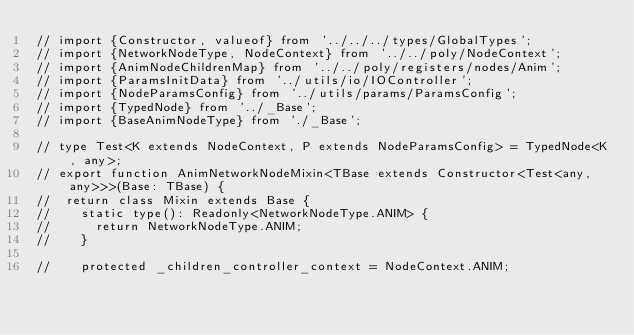<code> <loc_0><loc_0><loc_500><loc_500><_TypeScript_>// import {Constructor, valueof} from '../../../types/GlobalTypes';
// import {NetworkNodeType, NodeContext} from '../../poly/NodeContext';
// import {AnimNodeChildrenMap} from '../../poly/registers/nodes/Anim';
// import {ParamsInitData} from '../utils/io/IOController';
// import {NodeParamsConfig} from '../utils/params/ParamsConfig';
// import {TypedNode} from '../_Base';
// import {BaseAnimNodeType} from './_Base';

// type Test<K extends NodeContext, P extends NodeParamsConfig> = TypedNode<K, any>;
// export function AnimNetworkNodeMixin<TBase extends Constructor<Test<any, any>>>(Base: TBase) {
// 	return class Mixin extends Base {
// 		static type(): Readonly<NetworkNodeType.ANIM> {
// 			return NetworkNodeType.ANIM;
// 		}

// 		protected _children_controller_context = NodeContext.ANIM;
</code> 